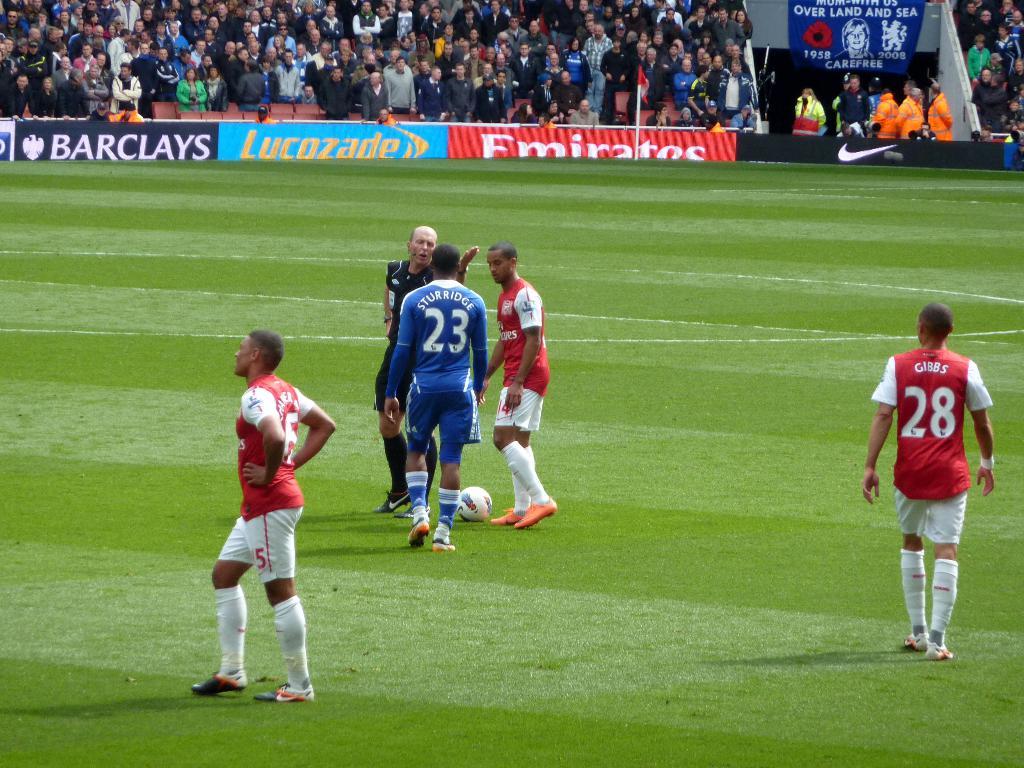What player number is in blue?
Keep it short and to the point. 23. What number is the player on the right in red?
Your answer should be very brief. 28. 